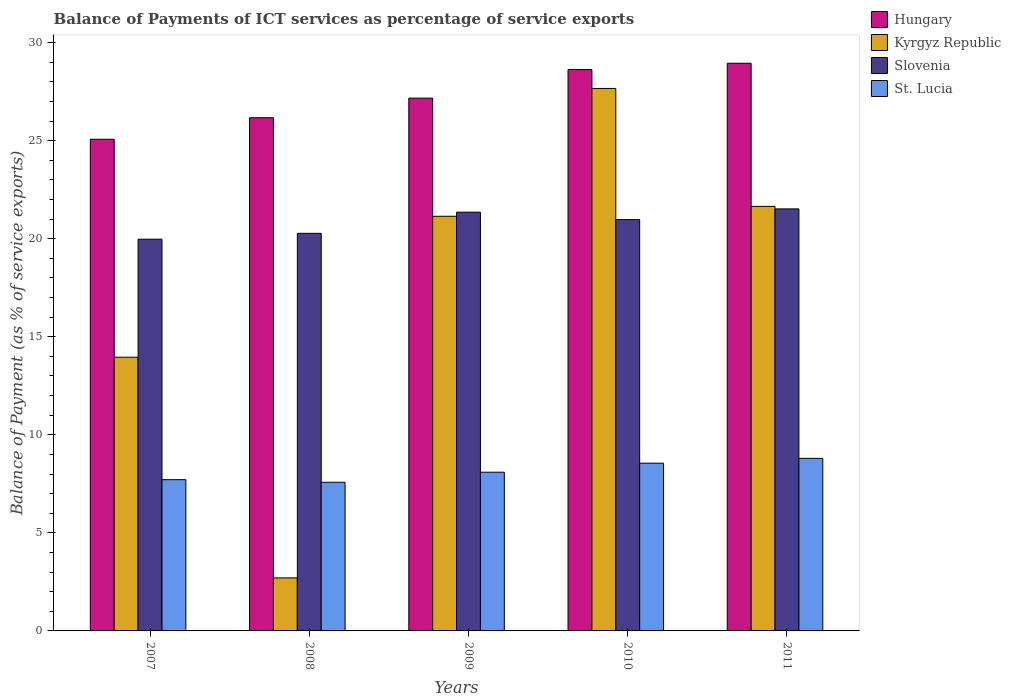How many different coloured bars are there?
Ensure brevity in your answer.  4. How many groups of bars are there?
Give a very brief answer. 5. Are the number of bars per tick equal to the number of legend labels?
Your answer should be compact. Yes. How many bars are there on the 3rd tick from the left?
Keep it short and to the point. 4. How many bars are there on the 4th tick from the right?
Your answer should be very brief. 4. In how many cases, is the number of bars for a given year not equal to the number of legend labels?
Ensure brevity in your answer.  0. What is the balance of payments of ICT services in Slovenia in 2011?
Provide a short and direct response. 21.52. Across all years, what is the maximum balance of payments of ICT services in St. Lucia?
Offer a terse response. 8.8. Across all years, what is the minimum balance of payments of ICT services in Hungary?
Ensure brevity in your answer.  25.07. In which year was the balance of payments of ICT services in Slovenia maximum?
Give a very brief answer. 2011. What is the total balance of payments of ICT services in St. Lucia in the graph?
Offer a very short reply. 40.74. What is the difference between the balance of payments of ICT services in Slovenia in 2007 and that in 2011?
Your answer should be compact. -1.55. What is the difference between the balance of payments of ICT services in St. Lucia in 2011 and the balance of payments of ICT services in Slovenia in 2007?
Make the answer very short. -11.17. What is the average balance of payments of ICT services in Hungary per year?
Your answer should be compact. 27.19. In the year 2007, what is the difference between the balance of payments of ICT services in Hungary and balance of payments of ICT services in Slovenia?
Keep it short and to the point. 5.1. What is the ratio of the balance of payments of ICT services in St. Lucia in 2007 to that in 2011?
Keep it short and to the point. 0.88. What is the difference between the highest and the second highest balance of payments of ICT services in Slovenia?
Make the answer very short. 0.17. What is the difference between the highest and the lowest balance of payments of ICT services in Slovenia?
Offer a terse response. 1.55. Is the sum of the balance of payments of ICT services in Hungary in 2009 and 2010 greater than the maximum balance of payments of ICT services in Kyrgyz Republic across all years?
Provide a succinct answer. Yes. Is it the case that in every year, the sum of the balance of payments of ICT services in St. Lucia and balance of payments of ICT services in Kyrgyz Republic is greater than the sum of balance of payments of ICT services in Hungary and balance of payments of ICT services in Slovenia?
Give a very brief answer. No. What does the 2nd bar from the left in 2007 represents?
Give a very brief answer. Kyrgyz Republic. What does the 3rd bar from the right in 2008 represents?
Ensure brevity in your answer.  Kyrgyz Republic. Is it the case that in every year, the sum of the balance of payments of ICT services in Hungary and balance of payments of ICT services in St. Lucia is greater than the balance of payments of ICT services in Kyrgyz Republic?
Offer a very short reply. Yes. Are all the bars in the graph horizontal?
Offer a very short reply. No. Where does the legend appear in the graph?
Keep it short and to the point. Top right. How many legend labels are there?
Provide a short and direct response. 4. What is the title of the graph?
Offer a terse response. Balance of Payments of ICT services as percentage of service exports. Does "Algeria" appear as one of the legend labels in the graph?
Provide a succinct answer. No. What is the label or title of the Y-axis?
Provide a succinct answer. Balance of Payment (as % of service exports). What is the Balance of Payment (as % of service exports) of Hungary in 2007?
Give a very brief answer. 25.07. What is the Balance of Payment (as % of service exports) of Kyrgyz Republic in 2007?
Your answer should be very brief. 13.96. What is the Balance of Payment (as % of service exports) of Slovenia in 2007?
Keep it short and to the point. 19.97. What is the Balance of Payment (as % of service exports) in St. Lucia in 2007?
Keep it short and to the point. 7.71. What is the Balance of Payment (as % of service exports) in Hungary in 2008?
Your response must be concise. 26.17. What is the Balance of Payment (as % of service exports) of Kyrgyz Republic in 2008?
Make the answer very short. 2.7. What is the Balance of Payment (as % of service exports) of Slovenia in 2008?
Provide a succinct answer. 20.27. What is the Balance of Payment (as % of service exports) of St. Lucia in 2008?
Offer a terse response. 7.58. What is the Balance of Payment (as % of service exports) in Hungary in 2009?
Keep it short and to the point. 27.17. What is the Balance of Payment (as % of service exports) of Kyrgyz Republic in 2009?
Your answer should be very brief. 21.14. What is the Balance of Payment (as % of service exports) of Slovenia in 2009?
Provide a short and direct response. 21.35. What is the Balance of Payment (as % of service exports) of St. Lucia in 2009?
Ensure brevity in your answer.  8.09. What is the Balance of Payment (as % of service exports) of Hungary in 2010?
Offer a very short reply. 28.62. What is the Balance of Payment (as % of service exports) of Kyrgyz Republic in 2010?
Provide a short and direct response. 27.66. What is the Balance of Payment (as % of service exports) in Slovenia in 2010?
Your answer should be very brief. 20.97. What is the Balance of Payment (as % of service exports) of St. Lucia in 2010?
Give a very brief answer. 8.55. What is the Balance of Payment (as % of service exports) of Hungary in 2011?
Offer a terse response. 28.94. What is the Balance of Payment (as % of service exports) of Kyrgyz Republic in 2011?
Offer a terse response. 21.65. What is the Balance of Payment (as % of service exports) in Slovenia in 2011?
Make the answer very short. 21.52. What is the Balance of Payment (as % of service exports) of St. Lucia in 2011?
Keep it short and to the point. 8.8. Across all years, what is the maximum Balance of Payment (as % of service exports) in Hungary?
Ensure brevity in your answer.  28.94. Across all years, what is the maximum Balance of Payment (as % of service exports) of Kyrgyz Republic?
Give a very brief answer. 27.66. Across all years, what is the maximum Balance of Payment (as % of service exports) of Slovenia?
Your answer should be compact. 21.52. Across all years, what is the maximum Balance of Payment (as % of service exports) of St. Lucia?
Give a very brief answer. 8.8. Across all years, what is the minimum Balance of Payment (as % of service exports) of Hungary?
Offer a terse response. 25.07. Across all years, what is the minimum Balance of Payment (as % of service exports) of Kyrgyz Republic?
Ensure brevity in your answer.  2.7. Across all years, what is the minimum Balance of Payment (as % of service exports) of Slovenia?
Your answer should be very brief. 19.97. Across all years, what is the minimum Balance of Payment (as % of service exports) of St. Lucia?
Make the answer very short. 7.58. What is the total Balance of Payment (as % of service exports) of Hungary in the graph?
Your response must be concise. 135.97. What is the total Balance of Payment (as % of service exports) in Kyrgyz Republic in the graph?
Offer a very short reply. 87.11. What is the total Balance of Payment (as % of service exports) of Slovenia in the graph?
Ensure brevity in your answer.  104.09. What is the total Balance of Payment (as % of service exports) of St. Lucia in the graph?
Your answer should be very brief. 40.74. What is the difference between the Balance of Payment (as % of service exports) in Hungary in 2007 and that in 2008?
Offer a terse response. -1.1. What is the difference between the Balance of Payment (as % of service exports) in Kyrgyz Republic in 2007 and that in 2008?
Provide a succinct answer. 11.25. What is the difference between the Balance of Payment (as % of service exports) in Slovenia in 2007 and that in 2008?
Your answer should be compact. -0.3. What is the difference between the Balance of Payment (as % of service exports) in St. Lucia in 2007 and that in 2008?
Offer a terse response. 0.13. What is the difference between the Balance of Payment (as % of service exports) of Hungary in 2007 and that in 2009?
Offer a very short reply. -2.1. What is the difference between the Balance of Payment (as % of service exports) in Kyrgyz Republic in 2007 and that in 2009?
Provide a succinct answer. -7.19. What is the difference between the Balance of Payment (as % of service exports) of Slovenia in 2007 and that in 2009?
Provide a succinct answer. -1.38. What is the difference between the Balance of Payment (as % of service exports) of St. Lucia in 2007 and that in 2009?
Ensure brevity in your answer.  -0.38. What is the difference between the Balance of Payment (as % of service exports) of Hungary in 2007 and that in 2010?
Provide a succinct answer. -3.55. What is the difference between the Balance of Payment (as % of service exports) of Kyrgyz Republic in 2007 and that in 2010?
Your response must be concise. -13.7. What is the difference between the Balance of Payment (as % of service exports) in Slovenia in 2007 and that in 2010?
Your answer should be compact. -1. What is the difference between the Balance of Payment (as % of service exports) in St. Lucia in 2007 and that in 2010?
Provide a succinct answer. -0.84. What is the difference between the Balance of Payment (as % of service exports) in Hungary in 2007 and that in 2011?
Your answer should be very brief. -3.88. What is the difference between the Balance of Payment (as % of service exports) in Kyrgyz Republic in 2007 and that in 2011?
Keep it short and to the point. -7.69. What is the difference between the Balance of Payment (as % of service exports) in Slovenia in 2007 and that in 2011?
Offer a very short reply. -1.55. What is the difference between the Balance of Payment (as % of service exports) in St. Lucia in 2007 and that in 2011?
Your answer should be very brief. -1.09. What is the difference between the Balance of Payment (as % of service exports) of Hungary in 2008 and that in 2009?
Give a very brief answer. -1. What is the difference between the Balance of Payment (as % of service exports) of Kyrgyz Republic in 2008 and that in 2009?
Keep it short and to the point. -18.44. What is the difference between the Balance of Payment (as % of service exports) of Slovenia in 2008 and that in 2009?
Your answer should be very brief. -1.08. What is the difference between the Balance of Payment (as % of service exports) of St. Lucia in 2008 and that in 2009?
Ensure brevity in your answer.  -0.51. What is the difference between the Balance of Payment (as % of service exports) of Hungary in 2008 and that in 2010?
Provide a short and direct response. -2.46. What is the difference between the Balance of Payment (as % of service exports) in Kyrgyz Republic in 2008 and that in 2010?
Make the answer very short. -24.96. What is the difference between the Balance of Payment (as % of service exports) in Slovenia in 2008 and that in 2010?
Provide a short and direct response. -0.7. What is the difference between the Balance of Payment (as % of service exports) in St. Lucia in 2008 and that in 2010?
Provide a short and direct response. -0.97. What is the difference between the Balance of Payment (as % of service exports) in Hungary in 2008 and that in 2011?
Provide a short and direct response. -2.78. What is the difference between the Balance of Payment (as % of service exports) of Kyrgyz Republic in 2008 and that in 2011?
Provide a succinct answer. -18.94. What is the difference between the Balance of Payment (as % of service exports) of Slovenia in 2008 and that in 2011?
Offer a terse response. -1.25. What is the difference between the Balance of Payment (as % of service exports) in St. Lucia in 2008 and that in 2011?
Your response must be concise. -1.22. What is the difference between the Balance of Payment (as % of service exports) of Hungary in 2009 and that in 2010?
Offer a very short reply. -1.46. What is the difference between the Balance of Payment (as % of service exports) of Kyrgyz Republic in 2009 and that in 2010?
Ensure brevity in your answer.  -6.52. What is the difference between the Balance of Payment (as % of service exports) of Slovenia in 2009 and that in 2010?
Give a very brief answer. 0.38. What is the difference between the Balance of Payment (as % of service exports) of St. Lucia in 2009 and that in 2010?
Provide a short and direct response. -0.46. What is the difference between the Balance of Payment (as % of service exports) of Hungary in 2009 and that in 2011?
Provide a succinct answer. -1.78. What is the difference between the Balance of Payment (as % of service exports) in Kyrgyz Republic in 2009 and that in 2011?
Your answer should be compact. -0.5. What is the difference between the Balance of Payment (as % of service exports) in Slovenia in 2009 and that in 2011?
Keep it short and to the point. -0.17. What is the difference between the Balance of Payment (as % of service exports) of St. Lucia in 2009 and that in 2011?
Keep it short and to the point. -0.71. What is the difference between the Balance of Payment (as % of service exports) of Hungary in 2010 and that in 2011?
Your answer should be compact. -0.32. What is the difference between the Balance of Payment (as % of service exports) in Kyrgyz Republic in 2010 and that in 2011?
Your response must be concise. 6.01. What is the difference between the Balance of Payment (as % of service exports) of Slovenia in 2010 and that in 2011?
Offer a terse response. -0.55. What is the difference between the Balance of Payment (as % of service exports) of St. Lucia in 2010 and that in 2011?
Make the answer very short. -0.25. What is the difference between the Balance of Payment (as % of service exports) in Hungary in 2007 and the Balance of Payment (as % of service exports) in Kyrgyz Republic in 2008?
Your response must be concise. 22.37. What is the difference between the Balance of Payment (as % of service exports) of Hungary in 2007 and the Balance of Payment (as % of service exports) of Slovenia in 2008?
Make the answer very short. 4.8. What is the difference between the Balance of Payment (as % of service exports) of Hungary in 2007 and the Balance of Payment (as % of service exports) of St. Lucia in 2008?
Provide a short and direct response. 17.49. What is the difference between the Balance of Payment (as % of service exports) of Kyrgyz Republic in 2007 and the Balance of Payment (as % of service exports) of Slovenia in 2008?
Your answer should be compact. -6.32. What is the difference between the Balance of Payment (as % of service exports) in Kyrgyz Republic in 2007 and the Balance of Payment (as % of service exports) in St. Lucia in 2008?
Provide a short and direct response. 6.38. What is the difference between the Balance of Payment (as % of service exports) of Slovenia in 2007 and the Balance of Payment (as % of service exports) of St. Lucia in 2008?
Provide a succinct answer. 12.39. What is the difference between the Balance of Payment (as % of service exports) in Hungary in 2007 and the Balance of Payment (as % of service exports) in Kyrgyz Republic in 2009?
Make the answer very short. 3.93. What is the difference between the Balance of Payment (as % of service exports) of Hungary in 2007 and the Balance of Payment (as % of service exports) of Slovenia in 2009?
Keep it short and to the point. 3.72. What is the difference between the Balance of Payment (as % of service exports) in Hungary in 2007 and the Balance of Payment (as % of service exports) in St. Lucia in 2009?
Make the answer very short. 16.98. What is the difference between the Balance of Payment (as % of service exports) in Kyrgyz Republic in 2007 and the Balance of Payment (as % of service exports) in Slovenia in 2009?
Your answer should be very brief. -7.39. What is the difference between the Balance of Payment (as % of service exports) in Kyrgyz Republic in 2007 and the Balance of Payment (as % of service exports) in St. Lucia in 2009?
Keep it short and to the point. 5.86. What is the difference between the Balance of Payment (as % of service exports) of Slovenia in 2007 and the Balance of Payment (as % of service exports) of St. Lucia in 2009?
Make the answer very short. 11.88. What is the difference between the Balance of Payment (as % of service exports) of Hungary in 2007 and the Balance of Payment (as % of service exports) of Kyrgyz Republic in 2010?
Offer a very short reply. -2.59. What is the difference between the Balance of Payment (as % of service exports) of Hungary in 2007 and the Balance of Payment (as % of service exports) of Slovenia in 2010?
Provide a short and direct response. 4.1. What is the difference between the Balance of Payment (as % of service exports) of Hungary in 2007 and the Balance of Payment (as % of service exports) of St. Lucia in 2010?
Offer a very short reply. 16.52. What is the difference between the Balance of Payment (as % of service exports) in Kyrgyz Republic in 2007 and the Balance of Payment (as % of service exports) in Slovenia in 2010?
Provide a short and direct response. -7.02. What is the difference between the Balance of Payment (as % of service exports) of Kyrgyz Republic in 2007 and the Balance of Payment (as % of service exports) of St. Lucia in 2010?
Offer a very short reply. 5.4. What is the difference between the Balance of Payment (as % of service exports) in Slovenia in 2007 and the Balance of Payment (as % of service exports) in St. Lucia in 2010?
Ensure brevity in your answer.  11.42. What is the difference between the Balance of Payment (as % of service exports) in Hungary in 2007 and the Balance of Payment (as % of service exports) in Kyrgyz Republic in 2011?
Keep it short and to the point. 3.42. What is the difference between the Balance of Payment (as % of service exports) in Hungary in 2007 and the Balance of Payment (as % of service exports) in Slovenia in 2011?
Provide a short and direct response. 3.55. What is the difference between the Balance of Payment (as % of service exports) of Hungary in 2007 and the Balance of Payment (as % of service exports) of St. Lucia in 2011?
Your answer should be compact. 16.27. What is the difference between the Balance of Payment (as % of service exports) of Kyrgyz Republic in 2007 and the Balance of Payment (as % of service exports) of Slovenia in 2011?
Provide a short and direct response. -7.56. What is the difference between the Balance of Payment (as % of service exports) in Kyrgyz Republic in 2007 and the Balance of Payment (as % of service exports) in St. Lucia in 2011?
Your answer should be compact. 5.16. What is the difference between the Balance of Payment (as % of service exports) of Slovenia in 2007 and the Balance of Payment (as % of service exports) of St. Lucia in 2011?
Keep it short and to the point. 11.17. What is the difference between the Balance of Payment (as % of service exports) of Hungary in 2008 and the Balance of Payment (as % of service exports) of Kyrgyz Republic in 2009?
Offer a terse response. 5.03. What is the difference between the Balance of Payment (as % of service exports) in Hungary in 2008 and the Balance of Payment (as % of service exports) in Slovenia in 2009?
Offer a very short reply. 4.82. What is the difference between the Balance of Payment (as % of service exports) in Hungary in 2008 and the Balance of Payment (as % of service exports) in St. Lucia in 2009?
Offer a very short reply. 18.08. What is the difference between the Balance of Payment (as % of service exports) of Kyrgyz Republic in 2008 and the Balance of Payment (as % of service exports) of Slovenia in 2009?
Make the answer very short. -18.65. What is the difference between the Balance of Payment (as % of service exports) of Kyrgyz Republic in 2008 and the Balance of Payment (as % of service exports) of St. Lucia in 2009?
Offer a terse response. -5.39. What is the difference between the Balance of Payment (as % of service exports) in Slovenia in 2008 and the Balance of Payment (as % of service exports) in St. Lucia in 2009?
Give a very brief answer. 12.18. What is the difference between the Balance of Payment (as % of service exports) in Hungary in 2008 and the Balance of Payment (as % of service exports) in Kyrgyz Republic in 2010?
Make the answer very short. -1.49. What is the difference between the Balance of Payment (as % of service exports) of Hungary in 2008 and the Balance of Payment (as % of service exports) of Slovenia in 2010?
Give a very brief answer. 5.19. What is the difference between the Balance of Payment (as % of service exports) in Hungary in 2008 and the Balance of Payment (as % of service exports) in St. Lucia in 2010?
Provide a short and direct response. 17.61. What is the difference between the Balance of Payment (as % of service exports) of Kyrgyz Republic in 2008 and the Balance of Payment (as % of service exports) of Slovenia in 2010?
Give a very brief answer. -18.27. What is the difference between the Balance of Payment (as % of service exports) of Kyrgyz Republic in 2008 and the Balance of Payment (as % of service exports) of St. Lucia in 2010?
Your answer should be compact. -5.85. What is the difference between the Balance of Payment (as % of service exports) of Slovenia in 2008 and the Balance of Payment (as % of service exports) of St. Lucia in 2010?
Provide a short and direct response. 11.72. What is the difference between the Balance of Payment (as % of service exports) in Hungary in 2008 and the Balance of Payment (as % of service exports) in Kyrgyz Republic in 2011?
Offer a terse response. 4.52. What is the difference between the Balance of Payment (as % of service exports) of Hungary in 2008 and the Balance of Payment (as % of service exports) of Slovenia in 2011?
Your answer should be very brief. 4.65. What is the difference between the Balance of Payment (as % of service exports) in Hungary in 2008 and the Balance of Payment (as % of service exports) in St. Lucia in 2011?
Your answer should be very brief. 17.37. What is the difference between the Balance of Payment (as % of service exports) of Kyrgyz Republic in 2008 and the Balance of Payment (as % of service exports) of Slovenia in 2011?
Keep it short and to the point. -18.82. What is the difference between the Balance of Payment (as % of service exports) of Kyrgyz Republic in 2008 and the Balance of Payment (as % of service exports) of St. Lucia in 2011?
Provide a short and direct response. -6.1. What is the difference between the Balance of Payment (as % of service exports) in Slovenia in 2008 and the Balance of Payment (as % of service exports) in St. Lucia in 2011?
Ensure brevity in your answer.  11.47. What is the difference between the Balance of Payment (as % of service exports) in Hungary in 2009 and the Balance of Payment (as % of service exports) in Kyrgyz Republic in 2010?
Give a very brief answer. -0.49. What is the difference between the Balance of Payment (as % of service exports) of Hungary in 2009 and the Balance of Payment (as % of service exports) of Slovenia in 2010?
Offer a terse response. 6.19. What is the difference between the Balance of Payment (as % of service exports) in Hungary in 2009 and the Balance of Payment (as % of service exports) in St. Lucia in 2010?
Your response must be concise. 18.61. What is the difference between the Balance of Payment (as % of service exports) in Kyrgyz Republic in 2009 and the Balance of Payment (as % of service exports) in Slovenia in 2010?
Give a very brief answer. 0.17. What is the difference between the Balance of Payment (as % of service exports) in Kyrgyz Republic in 2009 and the Balance of Payment (as % of service exports) in St. Lucia in 2010?
Keep it short and to the point. 12.59. What is the difference between the Balance of Payment (as % of service exports) in Slovenia in 2009 and the Balance of Payment (as % of service exports) in St. Lucia in 2010?
Make the answer very short. 12.8. What is the difference between the Balance of Payment (as % of service exports) in Hungary in 2009 and the Balance of Payment (as % of service exports) in Kyrgyz Republic in 2011?
Make the answer very short. 5.52. What is the difference between the Balance of Payment (as % of service exports) in Hungary in 2009 and the Balance of Payment (as % of service exports) in Slovenia in 2011?
Offer a terse response. 5.65. What is the difference between the Balance of Payment (as % of service exports) in Hungary in 2009 and the Balance of Payment (as % of service exports) in St. Lucia in 2011?
Offer a very short reply. 18.37. What is the difference between the Balance of Payment (as % of service exports) in Kyrgyz Republic in 2009 and the Balance of Payment (as % of service exports) in Slovenia in 2011?
Give a very brief answer. -0.38. What is the difference between the Balance of Payment (as % of service exports) in Kyrgyz Republic in 2009 and the Balance of Payment (as % of service exports) in St. Lucia in 2011?
Keep it short and to the point. 12.34. What is the difference between the Balance of Payment (as % of service exports) of Slovenia in 2009 and the Balance of Payment (as % of service exports) of St. Lucia in 2011?
Offer a very short reply. 12.55. What is the difference between the Balance of Payment (as % of service exports) in Hungary in 2010 and the Balance of Payment (as % of service exports) in Kyrgyz Republic in 2011?
Your answer should be very brief. 6.98. What is the difference between the Balance of Payment (as % of service exports) in Hungary in 2010 and the Balance of Payment (as % of service exports) in Slovenia in 2011?
Keep it short and to the point. 7.1. What is the difference between the Balance of Payment (as % of service exports) in Hungary in 2010 and the Balance of Payment (as % of service exports) in St. Lucia in 2011?
Provide a short and direct response. 19.82. What is the difference between the Balance of Payment (as % of service exports) of Kyrgyz Republic in 2010 and the Balance of Payment (as % of service exports) of Slovenia in 2011?
Provide a succinct answer. 6.14. What is the difference between the Balance of Payment (as % of service exports) of Kyrgyz Republic in 2010 and the Balance of Payment (as % of service exports) of St. Lucia in 2011?
Make the answer very short. 18.86. What is the difference between the Balance of Payment (as % of service exports) of Slovenia in 2010 and the Balance of Payment (as % of service exports) of St. Lucia in 2011?
Give a very brief answer. 12.17. What is the average Balance of Payment (as % of service exports) in Hungary per year?
Offer a terse response. 27.19. What is the average Balance of Payment (as % of service exports) of Kyrgyz Republic per year?
Your response must be concise. 17.42. What is the average Balance of Payment (as % of service exports) of Slovenia per year?
Make the answer very short. 20.82. What is the average Balance of Payment (as % of service exports) in St. Lucia per year?
Offer a very short reply. 8.15. In the year 2007, what is the difference between the Balance of Payment (as % of service exports) of Hungary and Balance of Payment (as % of service exports) of Kyrgyz Republic?
Give a very brief answer. 11.11. In the year 2007, what is the difference between the Balance of Payment (as % of service exports) of Hungary and Balance of Payment (as % of service exports) of Slovenia?
Offer a very short reply. 5.1. In the year 2007, what is the difference between the Balance of Payment (as % of service exports) of Hungary and Balance of Payment (as % of service exports) of St. Lucia?
Offer a very short reply. 17.36. In the year 2007, what is the difference between the Balance of Payment (as % of service exports) in Kyrgyz Republic and Balance of Payment (as % of service exports) in Slovenia?
Provide a short and direct response. -6.02. In the year 2007, what is the difference between the Balance of Payment (as % of service exports) of Kyrgyz Republic and Balance of Payment (as % of service exports) of St. Lucia?
Keep it short and to the point. 6.25. In the year 2007, what is the difference between the Balance of Payment (as % of service exports) of Slovenia and Balance of Payment (as % of service exports) of St. Lucia?
Offer a very short reply. 12.26. In the year 2008, what is the difference between the Balance of Payment (as % of service exports) of Hungary and Balance of Payment (as % of service exports) of Kyrgyz Republic?
Keep it short and to the point. 23.46. In the year 2008, what is the difference between the Balance of Payment (as % of service exports) in Hungary and Balance of Payment (as % of service exports) in Slovenia?
Provide a succinct answer. 5.9. In the year 2008, what is the difference between the Balance of Payment (as % of service exports) in Hungary and Balance of Payment (as % of service exports) in St. Lucia?
Your answer should be compact. 18.59. In the year 2008, what is the difference between the Balance of Payment (as % of service exports) in Kyrgyz Republic and Balance of Payment (as % of service exports) in Slovenia?
Your answer should be very brief. -17.57. In the year 2008, what is the difference between the Balance of Payment (as % of service exports) of Kyrgyz Republic and Balance of Payment (as % of service exports) of St. Lucia?
Your answer should be compact. -4.88. In the year 2008, what is the difference between the Balance of Payment (as % of service exports) in Slovenia and Balance of Payment (as % of service exports) in St. Lucia?
Your answer should be very brief. 12.69. In the year 2009, what is the difference between the Balance of Payment (as % of service exports) in Hungary and Balance of Payment (as % of service exports) in Kyrgyz Republic?
Ensure brevity in your answer.  6.02. In the year 2009, what is the difference between the Balance of Payment (as % of service exports) in Hungary and Balance of Payment (as % of service exports) in Slovenia?
Your answer should be compact. 5.81. In the year 2009, what is the difference between the Balance of Payment (as % of service exports) in Hungary and Balance of Payment (as % of service exports) in St. Lucia?
Provide a succinct answer. 19.07. In the year 2009, what is the difference between the Balance of Payment (as % of service exports) of Kyrgyz Republic and Balance of Payment (as % of service exports) of Slovenia?
Your answer should be compact. -0.21. In the year 2009, what is the difference between the Balance of Payment (as % of service exports) of Kyrgyz Republic and Balance of Payment (as % of service exports) of St. Lucia?
Your response must be concise. 13.05. In the year 2009, what is the difference between the Balance of Payment (as % of service exports) in Slovenia and Balance of Payment (as % of service exports) in St. Lucia?
Your answer should be very brief. 13.26. In the year 2010, what is the difference between the Balance of Payment (as % of service exports) of Hungary and Balance of Payment (as % of service exports) of Kyrgyz Republic?
Give a very brief answer. 0.96. In the year 2010, what is the difference between the Balance of Payment (as % of service exports) in Hungary and Balance of Payment (as % of service exports) in Slovenia?
Your answer should be very brief. 7.65. In the year 2010, what is the difference between the Balance of Payment (as % of service exports) of Hungary and Balance of Payment (as % of service exports) of St. Lucia?
Provide a short and direct response. 20.07. In the year 2010, what is the difference between the Balance of Payment (as % of service exports) in Kyrgyz Republic and Balance of Payment (as % of service exports) in Slovenia?
Your answer should be compact. 6.69. In the year 2010, what is the difference between the Balance of Payment (as % of service exports) in Kyrgyz Republic and Balance of Payment (as % of service exports) in St. Lucia?
Offer a very short reply. 19.11. In the year 2010, what is the difference between the Balance of Payment (as % of service exports) in Slovenia and Balance of Payment (as % of service exports) in St. Lucia?
Provide a succinct answer. 12.42. In the year 2011, what is the difference between the Balance of Payment (as % of service exports) of Hungary and Balance of Payment (as % of service exports) of Kyrgyz Republic?
Make the answer very short. 7.3. In the year 2011, what is the difference between the Balance of Payment (as % of service exports) of Hungary and Balance of Payment (as % of service exports) of Slovenia?
Provide a succinct answer. 7.43. In the year 2011, what is the difference between the Balance of Payment (as % of service exports) of Hungary and Balance of Payment (as % of service exports) of St. Lucia?
Provide a short and direct response. 20.14. In the year 2011, what is the difference between the Balance of Payment (as % of service exports) in Kyrgyz Republic and Balance of Payment (as % of service exports) in Slovenia?
Make the answer very short. 0.13. In the year 2011, what is the difference between the Balance of Payment (as % of service exports) in Kyrgyz Republic and Balance of Payment (as % of service exports) in St. Lucia?
Your answer should be very brief. 12.85. In the year 2011, what is the difference between the Balance of Payment (as % of service exports) of Slovenia and Balance of Payment (as % of service exports) of St. Lucia?
Keep it short and to the point. 12.72. What is the ratio of the Balance of Payment (as % of service exports) of Hungary in 2007 to that in 2008?
Make the answer very short. 0.96. What is the ratio of the Balance of Payment (as % of service exports) of Kyrgyz Republic in 2007 to that in 2008?
Provide a succinct answer. 5.16. What is the ratio of the Balance of Payment (as % of service exports) of Slovenia in 2007 to that in 2008?
Make the answer very short. 0.99. What is the ratio of the Balance of Payment (as % of service exports) of St. Lucia in 2007 to that in 2008?
Your response must be concise. 1.02. What is the ratio of the Balance of Payment (as % of service exports) in Hungary in 2007 to that in 2009?
Offer a very short reply. 0.92. What is the ratio of the Balance of Payment (as % of service exports) of Kyrgyz Republic in 2007 to that in 2009?
Ensure brevity in your answer.  0.66. What is the ratio of the Balance of Payment (as % of service exports) in Slovenia in 2007 to that in 2009?
Your answer should be very brief. 0.94. What is the ratio of the Balance of Payment (as % of service exports) in St. Lucia in 2007 to that in 2009?
Your answer should be compact. 0.95. What is the ratio of the Balance of Payment (as % of service exports) of Hungary in 2007 to that in 2010?
Provide a short and direct response. 0.88. What is the ratio of the Balance of Payment (as % of service exports) of Kyrgyz Republic in 2007 to that in 2010?
Make the answer very short. 0.5. What is the ratio of the Balance of Payment (as % of service exports) of Slovenia in 2007 to that in 2010?
Keep it short and to the point. 0.95. What is the ratio of the Balance of Payment (as % of service exports) of St. Lucia in 2007 to that in 2010?
Provide a short and direct response. 0.9. What is the ratio of the Balance of Payment (as % of service exports) of Hungary in 2007 to that in 2011?
Provide a short and direct response. 0.87. What is the ratio of the Balance of Payment (as % of service exports) in Kyrgyz Republic in 2007 to that in 2011?
Provide a succinct answer. 0.64. What is the ratio of the Balance of Payment (as % of service exports) of Slovenia in 2007 to that in 2011?
Your response must be concise. 0.93. What is the ratio of the Balance of Payment (as % of service exports) in St. Lucia in 2007 to that in 2011?
Your answer should be compact. 0.88. What is the ratio of the Balance of Payment (as % of service exports) of Hungary in 2008 to that in 2009?
Your answer should be very brief. 0.96. What is the ratio of the Balance of Payment (as % of service exports) of Kyrgyz Republic in 2008 to that in 2009?
Ensure brevity in your answer.  0.13. What is the ratio of the Balance of Payment (as % of service exports) in Slovenia in 2008 to that in 2009?
Provide a succinct answer. 0.95. What is the ratio of the Balance of Payment (as % of service exports) in St. Lucia in 2008 to that in 2009?
Your response must be concise. 0.94. What is the ratio of the Balance of Payment (as % of service exports) of Hungary in 2008 to that in 2010?
Your response must be concise. 0.91. What is the ratio of the Balance of Payment (as % of service exports) in Kyrgyz Republic in 2008 to that in 2010?
Your answer should be compact. 0.1. What is the ratio of the Balance of Payment (as % of service exports) of Slovenia in 2008 to that in 2010?
Your answer should be compact. 0.97. What is the ratio of the Balance of Payment (as % of service exports) in St. Lucia in 2008 to that in 2010?
Keep it short and to the point. 0.89. What is the ratio of the Balance of Payment (as % of service exports) of Hungary in 2008 to that in 2011?
Ensure brevity in your answer.  0.9. What is the ratio of the Balance of Payment (as % of service exports) in Kyrgyz Republic in 2008 to that in 2011?
Ensure brevity in your answer.  0.12. What is the ratio of the Balance of Payment (as % of service exports) of Slovenia in 2008 to that in 2011?
Your answer should be compact. 0.94. What is the ratio of the Balance of Payment (as % of service exports) of St. Lucia in 2008 to that in 2011?
Offer a very short reply. 0.86. What is the ratio of the Balance of Payment (as % of service exports) of Hungary in 2009 to that in 2010?
Ensure brevity in your answer.  0.95. What is the ratio of the Balance of Payment (as % of service exports) of Kyrgyz Republic in 2009 to that in 2010?
Make the answer very short. 0.76. What is the ratio of the Balance of Payment (as % of service exports) in Slovenia in 2009 to that in 2010?
Your answer should be very brief. 1.02. What is the ratio of the Balance of Payment (as % of service exports) in St. Lucia in 2009 to that in 2010?
Provide a short and direct response. 0.95. What is the ratio of the Balance of Payment (as % of service exports) of Hungary in 2009 to that in 2011?
Provide a succinct answer. 0.94. What is the ratio of the Balance of Payment (as % of service exports) of Kyrgyz Republic in 2009 to that in 2011?
Give a very brief answer. 0.98. What is the ratio of the Balance of Payment (as % of service exports) in St. Lucia in 2009 to that in 2011?
Your answer should be compact. 0.92. What is the ratio of the Balance of Payment (as % of service exports) in Hungary in 2010 to that in 2011?
Provide a short and direct response. 0.99. What is the ratio of the Balance of Payment (as % of service exports) in Kyrgyz Republic in 2010 to that in 2011?
Your response must be concise. 1.28. What is the ratio of the Balance of Payment (as % of service exports) in Slovenia in 2010 to that in 2011?
Make the answer very short. 0.97. What is the ratio of the Balance of Payment (as % of service exports) in St. Lucia in 2010 to that in 2011?
Make the answer very short. 0.97. What is the difference between the highest and the second highest Balance of Payment (as % of service exports) of Hungary?
Give a very brief answer. 0.32. What is the difference between the highest and the second highest Balance of Payment (as % of service exports) of Kyrgyz Republic?
Keep it short and to the point. 6.01. What is the difference between the highest and the second highest Balance of Payment (as % of service exports) of Slovenia?
Offer a very short reply. 0.17. What is the difference between the highest and the second highest Balance of Payment (as % of service exports) of St. Lucia?
Your answer should be very brief. 0.25. What is the difference between the highest and the lowest Balance of Payment (as % of service exports) of Hungary?
Make the answer very short. 3.88. What is the difference between the highest and the lowest Balance of Payment (as % of service exports) of Kyrgyz Republic?
Keep it short and to the point. 24.96. What is the difference between the highest and the lowest Balance of Payment (as % of service exports) in Slovenia?
Your answer should be very brief. 1.55. What is the difference between the highest and the lowest Balance of Payment (as % of service exports) in St. Lucia?
Provide a short and direct response. 1.22. 